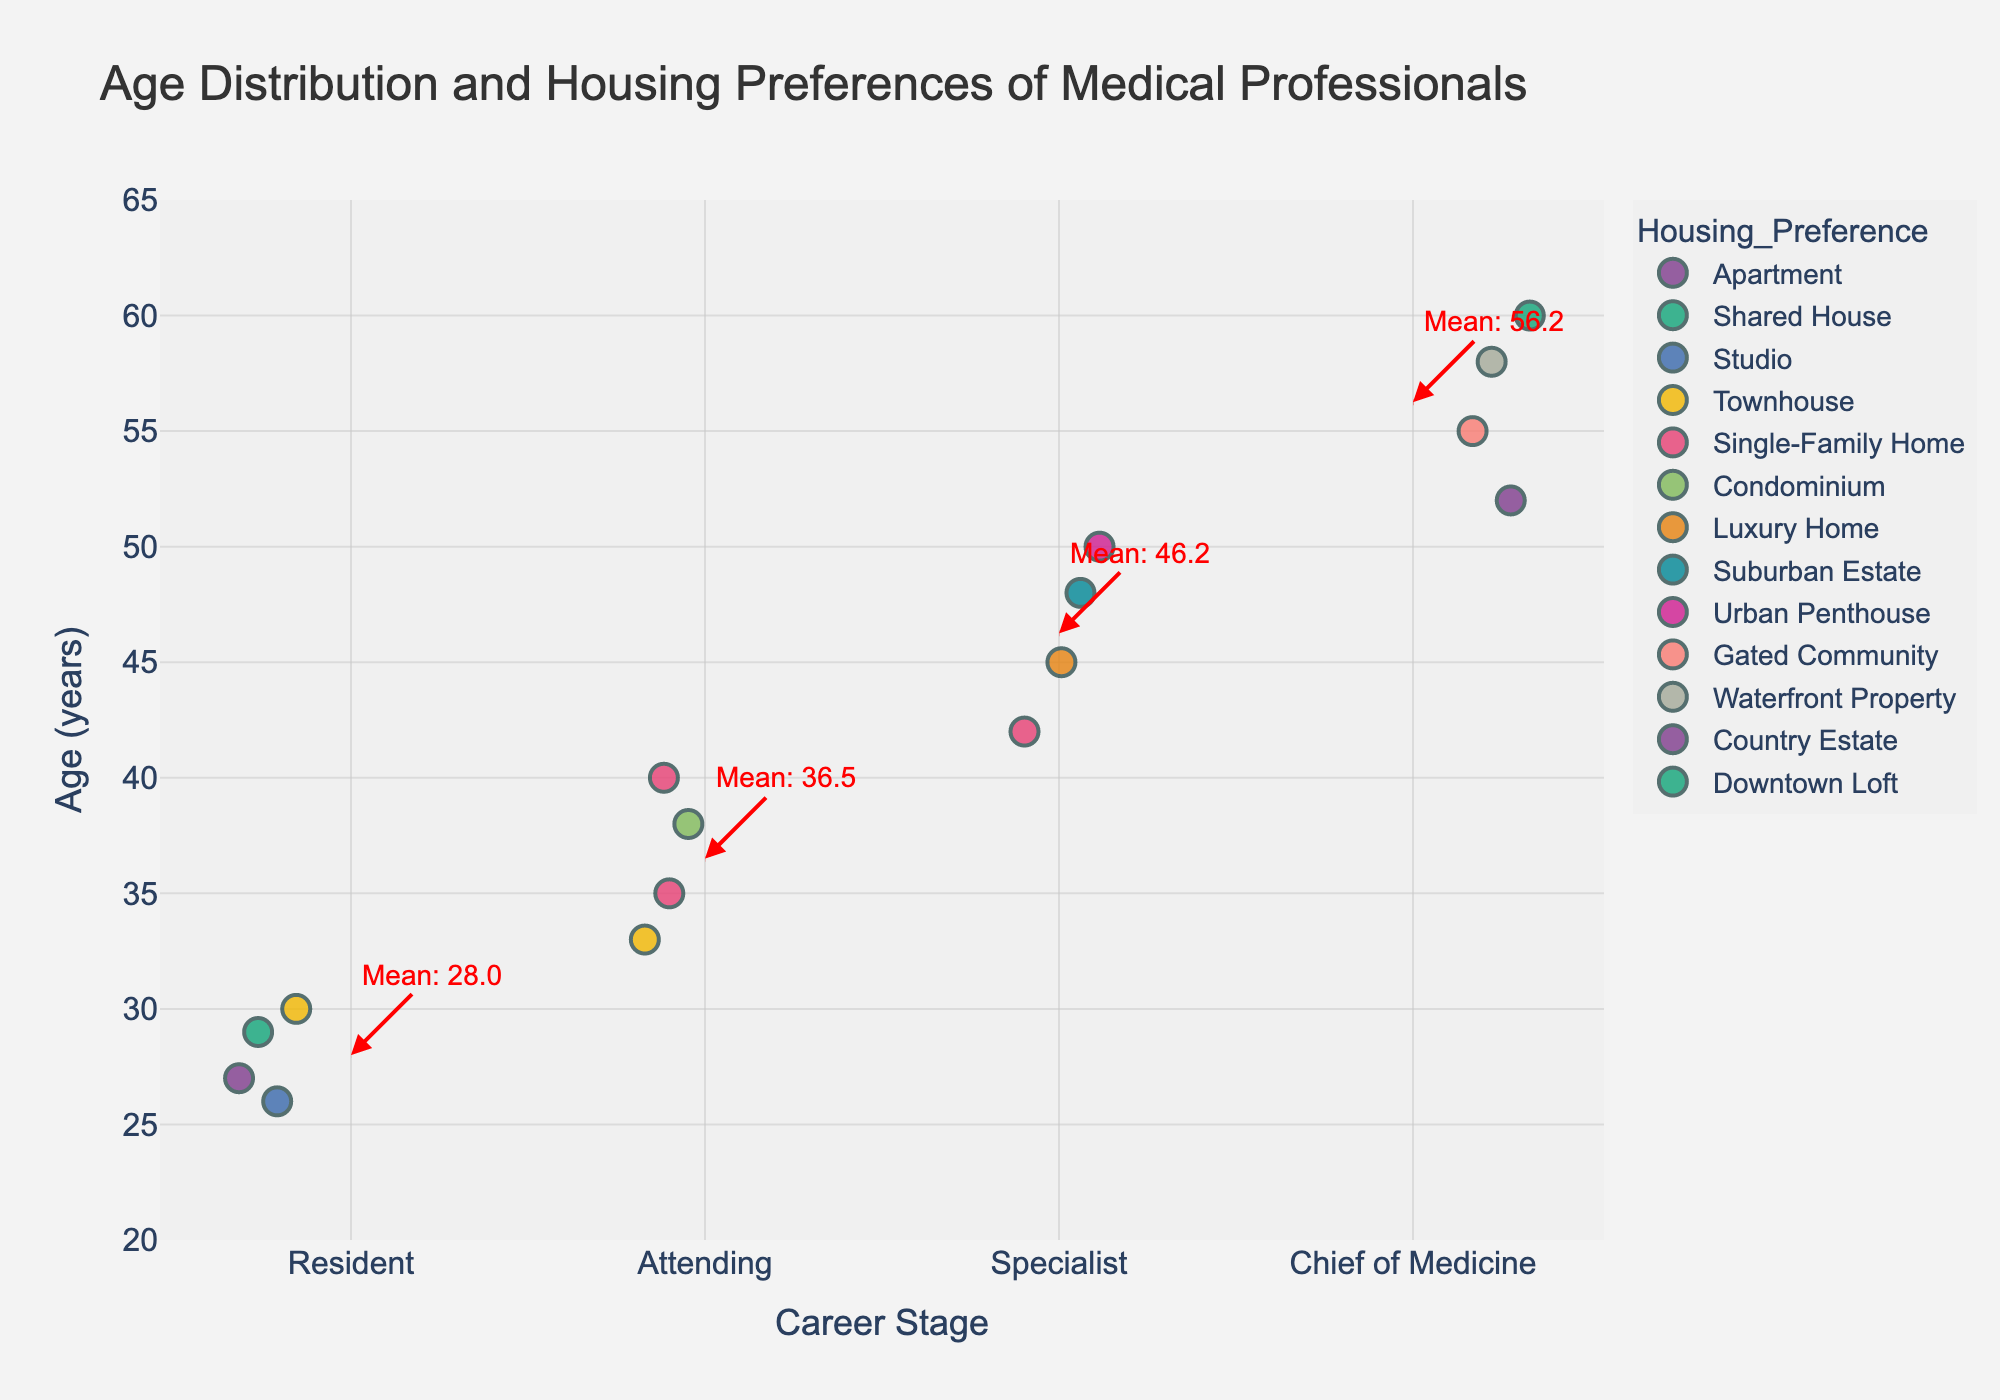What is the title of the plot? The title is usually displayed at the top of the plot. In this case, one can find it directly written in a large font.
Answer: Age Distribution and Housing Preferences of Medical Professionals What is the range of ages depicted in the plot? To determine the range of ages, look at the numerical values on the y-axis to identify the minimum and maximum ages.
Answer: 20 to 65 What is the most common housing preference for Residents? By examining the colors associated with "Resident" points on the plot, observe which housing type appears most frequently.
Answer: Apartment Which career stage has the highest mean age? The plot includes dotted lines with annotations indicating the mean age for each career stage. Compare the values next to "Mean" for all stages.
Answer: Chief of Medicine What is the mean age of Attending medical professionals? Locate the line and annotation for the Attending category; the annotation will state the mean age.
Answer: 36.5 How does the mean age of Specialists compare to Residents? Using the annotations for mean ages, subtract the mean age of Residents from the mean age of Specialists to find the difference.
Answer: 45 - 28 = 17 years difference Which career stage has the most diverse range of housing preferences? Examine the different colors (representing housing preferences) within each career stage to see which has the most variety.
Answer: Chief of Medicine What kind of housing is most popular among Specialists aged 45 to 50? Look at the specific ages within the Specialist category and count the occurrences of different housing preferences within that age range.
Answer: Luxury Home Are there any career stages where no single-family homes are preferred? Identify the absence of single-family home markers (colors) within each career stage.
Answer: Resident Which age group is more likely to choose a shared house, Residents or Attendings? Compare the number of shared house markers (color) in the Resident and Attending categories to find which has more occurrences.
Answer: Residents 